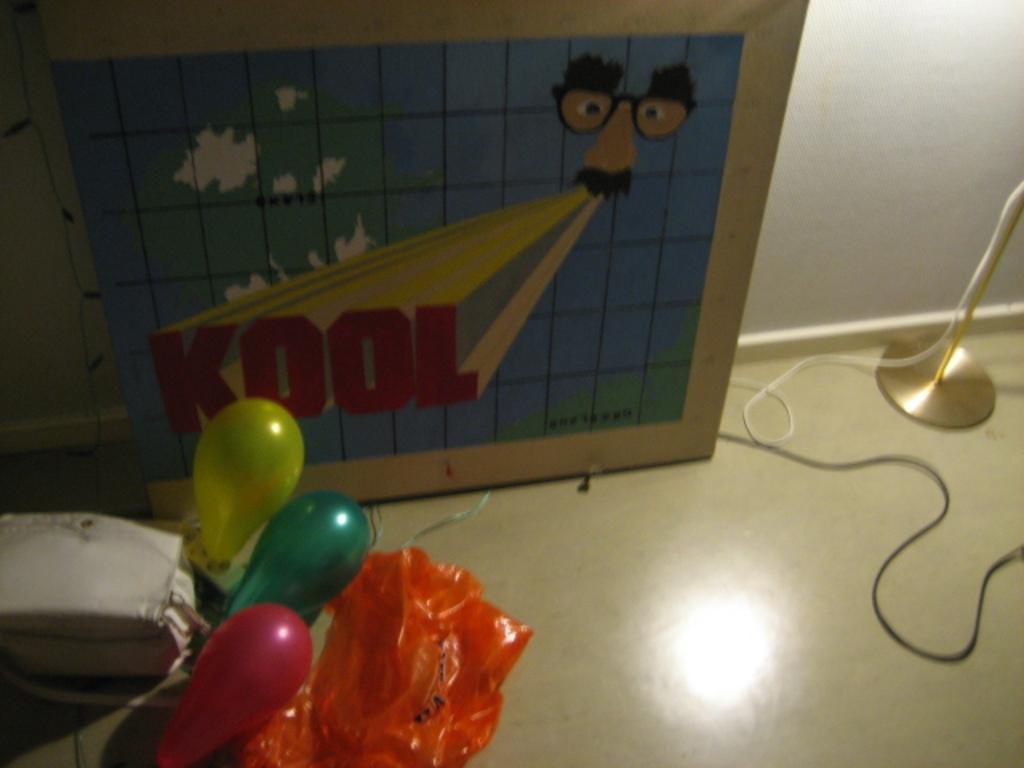Describe this image in one or two sentences. In this image I can see three balloons, a white colour bag, an orange colour thing, a board, wires, a pole and on this board I can see something is written. I can also see colour of these balloons are yellow, green and red. 